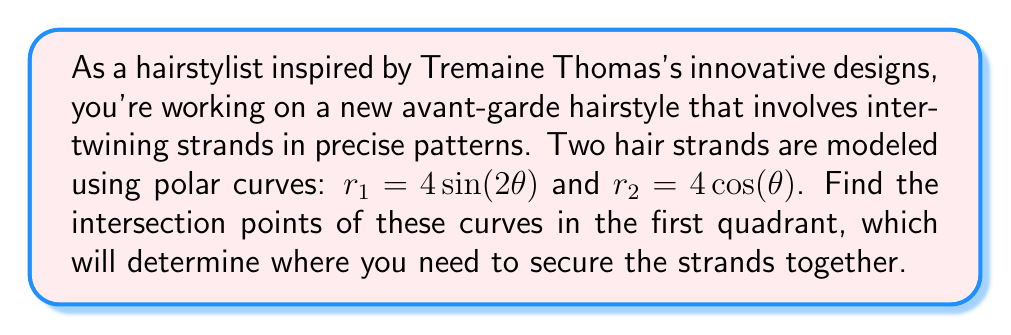Could you help me with this problem? To find the intersection points of the two polar curves, we need to solve the equation:

$$ 4\sin(2\theta) = 4\cos(\theta) $$

Let's solve this step-by-step:

1) First, simplify by dividing both sides by 4:

   $$ \sin(2\theta) = \cos(\theta) $$

2) Use the double angle formula for sine:

   $$ 2\sin(\theta)\cos(\theta) = \cos(\theta) $$

3) Divide both sides by $\cos(\theta)$ (assuming $\cos(\theta) \neq 0$):

   $$ 2\sin(\theta) = 1 $$

4) Solve for $\theta$:

   $$ \sin(\theta) = \frac{1}{2} $$
   $$ \theta = \arcsin(\frac{1}{2}) = \frac{\pi}{6} \approx 0.5236 \text{ radians} $$

5) This is the solution in the first quadrant. To find the $r$ coordinate, we can use either of the original equations. Let's use $r_1$:

   $$ r = 4\sin(2(\frac{\pi}{6})) = 4\sin(\frac{\pi}{3}) = 4 \cdot \frac{\sqrt{3}}{2} = 2\sqrt{3} $$

6) Convert to rectangular coordinates:

   $$ x = r\cos(\theta) = 2\sqrt{3} \cdot \frac{\sqrt{3}}{2} = 3 $$
   $$ y = r\sin(\theta) = 2\sqrt{3} \cdot \frac{1}{2} = \sqrt{3} $$

Therefore, the intersection point in the first quadrant is $(3, \sqrt{3})$ in rectangular coordinates, or $(2\sqrt{3}, \frac{\pi}{6})$ in polar coordinates.

[asy]
import graph;
size(200);
real f1(real t) {return 4*sin(2*t);}
real f2(real t) {return 4*cos(t);}
draw(polargraph(f1,0,pi,operator ..),blue);
draw(polargraph(f2,0,pi,operator ..),red);
dot((3,sqrt(3)),linewidth(4));
label("Intersection",(3,sqrt(3)),NE);
xaxis("x");
yaxis("y");
[/asy]
Answer: The intersection point in the first quadrant is $(3, \sqrt{3})$ in rectangular coordinates, or $(2\sqrt{3}, \frac{\pi}{6})$ in polar coordinates. 